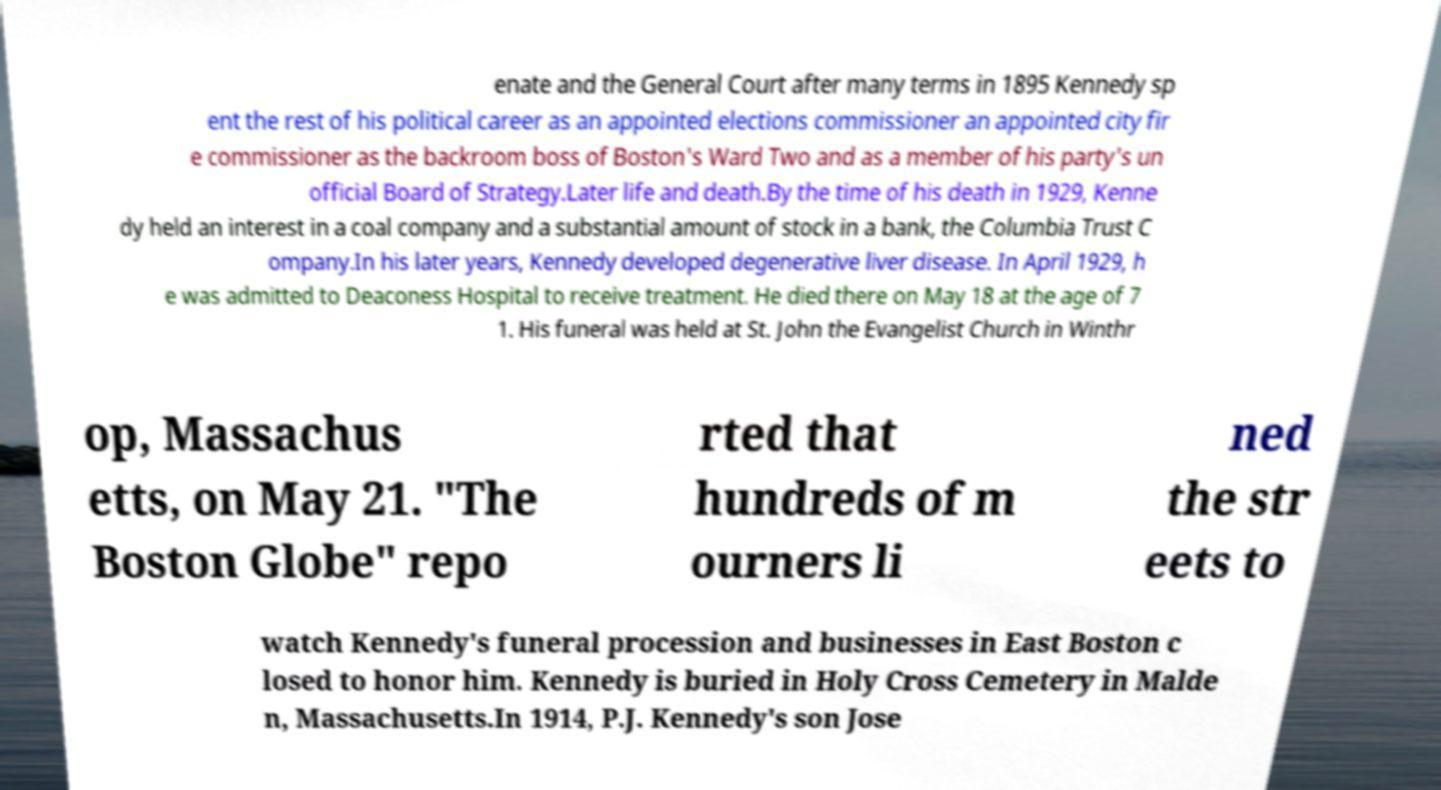Could you assist in decoding the text presented in this image and type it out clearly? enate and the General Court after many terms in 1895 Kennedy sp ent the rest of his political career as an appointed elections commissioner an appointed city fir e commissioner as the backroom boss of Boston's Ward Two and as a member of his party's un official Board of Strategy.Later life and death.By the time of his death in 1929, Kenne dy held an interest in a coal company and a substantial amount of stock in a bank, the Columbia Trust C ompany.In his later years, Kennedy developed degenerative liver disease. In April 1929, h e was admitted to Deaconess Hospital to receive treatment. He died there on May 18 at the age of 7 1. His funeral was held at St. John the Evangelist Church in Winthr op, Massachus etts, on May 21. "The Boston Globe" repo rted that hundreds of m ourners li ned the str eets to watch Kennedy's funeral procession and businesses in East Boston c losed to honor him. Kennedy is buried in Holy Cross Cemetery in Malde n, Massachusetts.In 1914, P.J. Kennedy's son Jose 